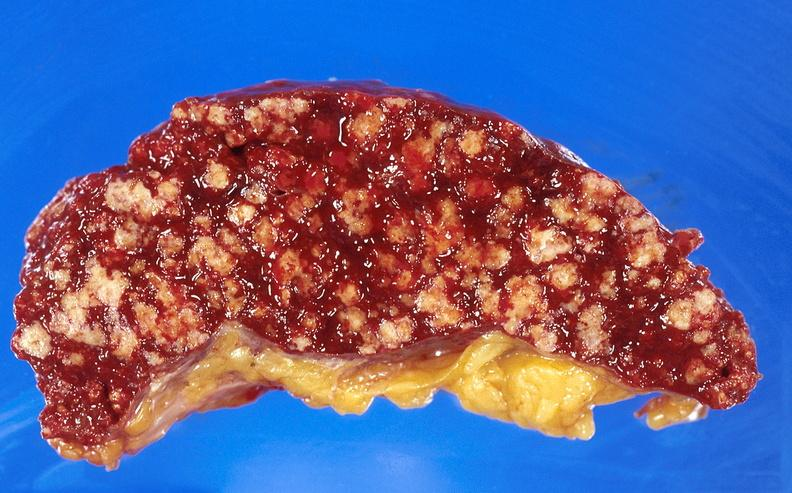does this image show spleen, tuberculosis?
Answer the question using a single word or phrase. Yes 